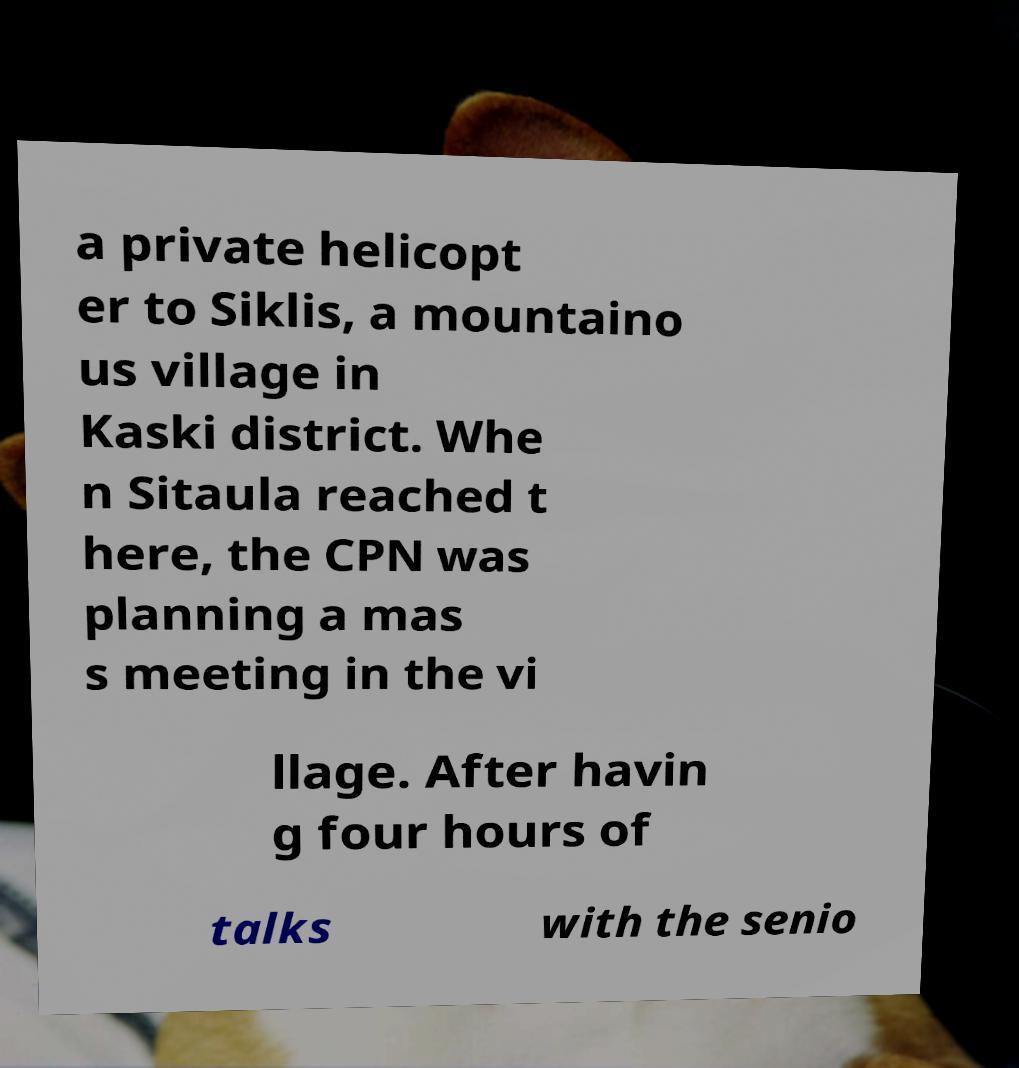There's text embedded in this image that I need extracted. Can you transcribe it verbatim? a private helicopt er to Siklis, a mountaino us village in Kaski district. Whe n Sitaula reached t here, the CPN was planning a mas s meeting in the vi llage. After havin g four hours of talks with the senio 